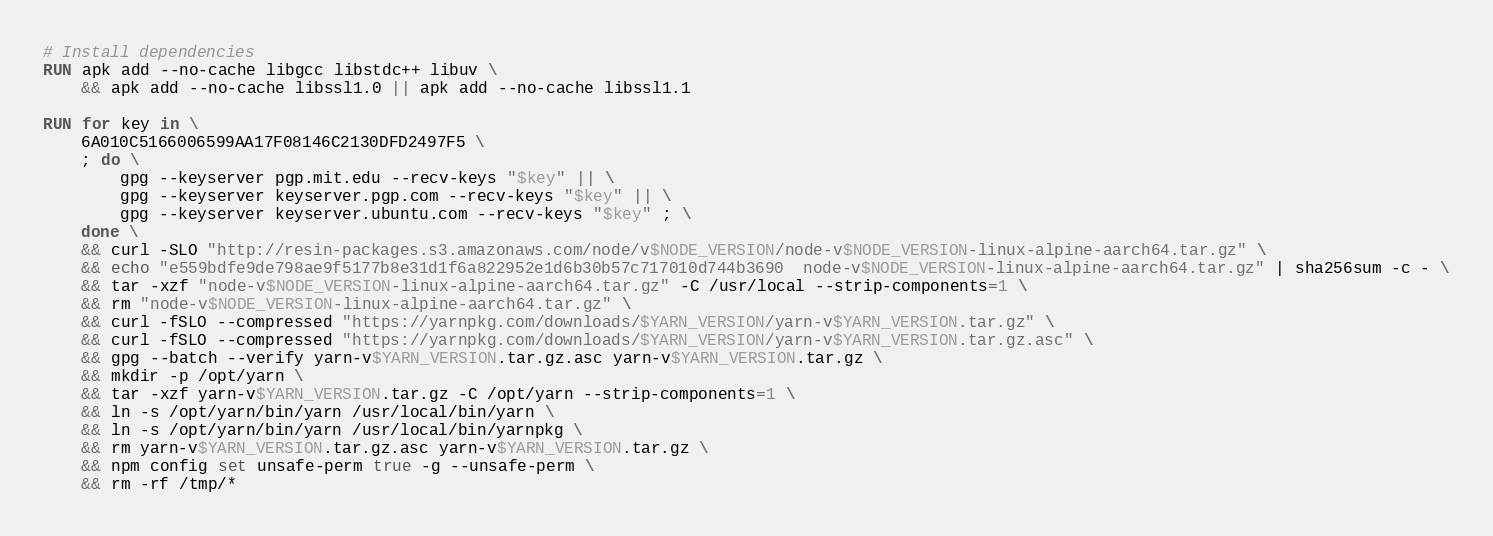<code> <loc_0><loc_0><loc_500><loc_500><_Dockerfile_># Install dependencies
RUN apk add --no-cache libgcc libstdc++ libuv \
	&& apk add --no-cache libssl1.0 || apk add --no-cache libssl1.1

RUN for key in \
	6A010C5166006599AA17F08146C2130DFD2497F5 \
	; do \
		gpg --keyserver pgp.mit.edu --recv-keys "$key" || \
		gpg --keyserver keyserver.pgp.com --recv-keys "$key" || \
		gpg --keyserver keyserver.ubuntu.com --recv-keys "$key" ; \
	done \
	&& curl -SLO "http://resin-packages.s3.amazonaws.com/node/v$NODE_VERSION/node-v$NODE_VERSION-linux-alpine-aarch64.tar.gz" \
	&& echo "e559bdfe9de798ae9f5177b8e31d1f6a822952e1d6b30b57c717010d744b3690  node-v$NODE_VERSION-linux-alpine-aarch64.tar.gz" | sha256sum -c - \
	&& tar -xzf "node-v$NODE_VERSION-linux-alpine-aarch64.tar.gz" -C /usr/local --strip-components=1 \
	&& rm "node-v$NODE_VERSION-linux-alpine-aarch64.tar.gz" \
	&& curl -fSLO --compressed "https://yarnpkg.com/downloads/$YARN_VERSION/yarn-v$YARN_VERSION.tar.gz" \
	&& curl -fSLO --compressed "https://yarnpkg.com/downloads/$YARN_VERSION/yarn-v$YARN_VERSION.tar.gz.asc" \
	&& gpg --batch --verify yarn-v$YARN_VERSION.tar.gz.asc yarn-v$YARN_VERSION.tar.gz \
	&& mkdir -p /opt/yarn \
	&& tar -xzf yarn-v$YARN_VERSION.tar.gz -C /opt/yarn --strip-components=1 \
	&& ln -s /opt/yarn/bin/yarn /usr/local/bin/yarn \
	&& ln -s /opt/yarn/bin/yarn /usr/local/bin/yarnpkg \
	&& rm yarn-v$YARN_VERSION.tar.gz.asc yarn-v$YARN_VERSION.tar.gz \
	&& npm config set unsafe-perm true -g --unsafe-perm \
	&& rm -rf /tmp/*
</code> 